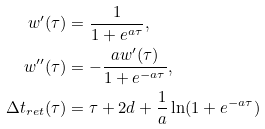<formula> <loc_0><loc_0><loc_500><loc_500>w ^ { \prime } ( \tau ) & = \frac { 1 } { 1 + e ^ { a \tau } } , \\ w ^ { \prime \prime } ( \tau ) & = - \frac { a w ^ { \prime } ( \tau ) } { 1 + e ^ { - a \tau } } , \\ \Delta { t } _ { r e t } ( \tau ) & = \tau + 2 d + \frac { 1 } { a } \ln ( 1 + e ^ { - a \tau } )</formula> 